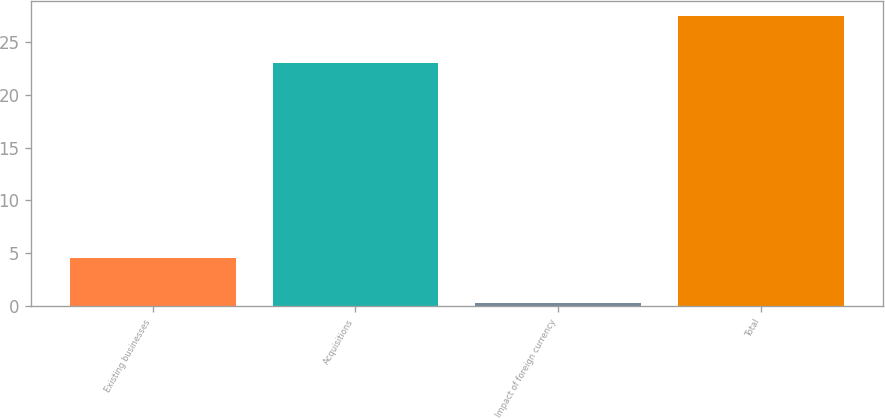<chart> <loc_0><loc_0><loc_500><loc_500><bar_chart><fcel>Existing businesses<fcel>Acquisitions<fcel>Impact of foreign currency<fcel>Total<nl><fcel>4.5<fcel>23<fcel>0.26<fcel>27.5<nl></chart> 